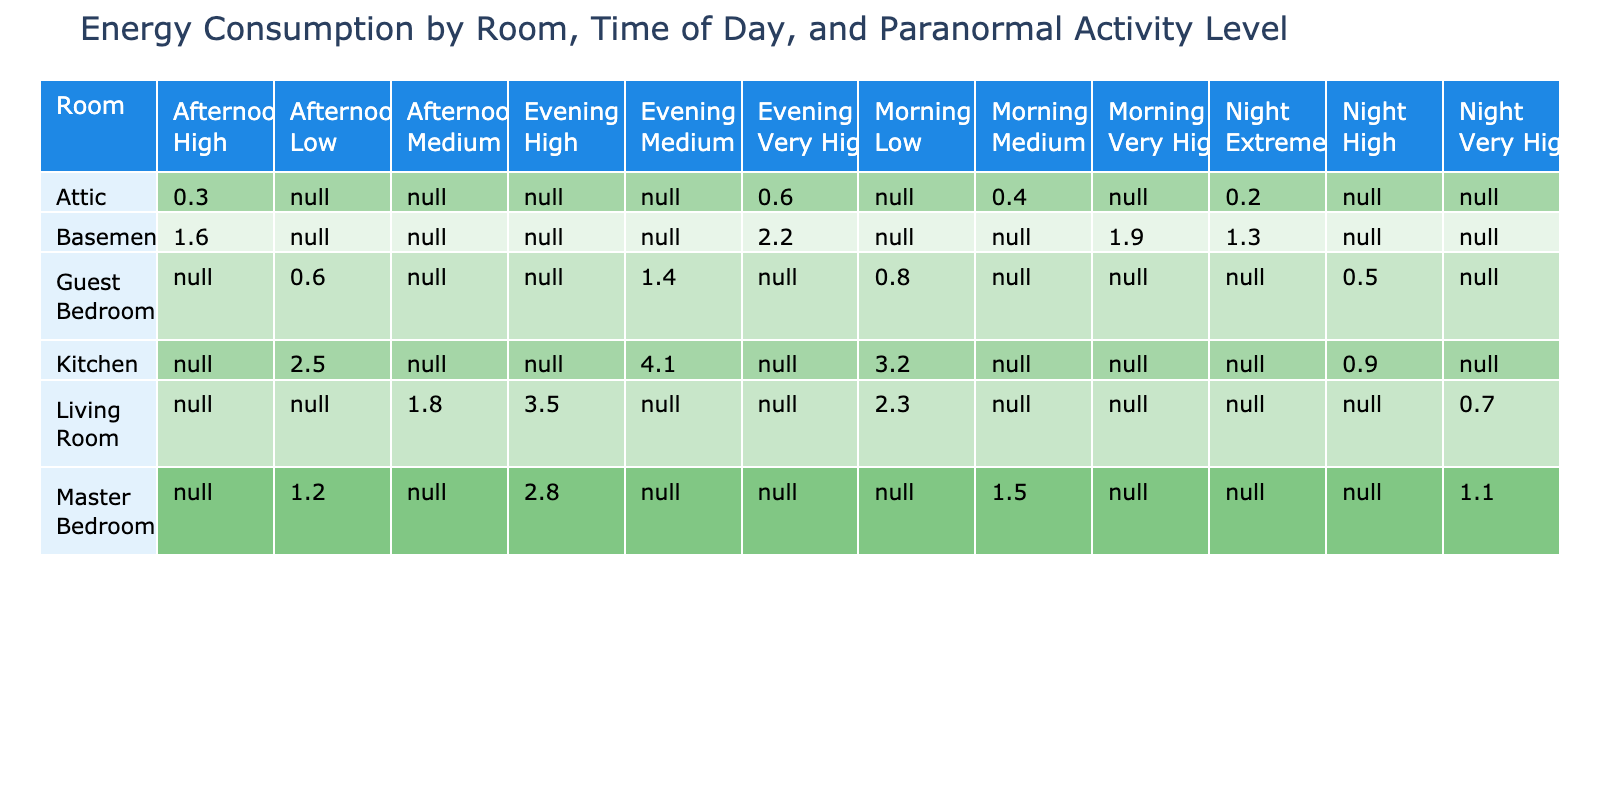What is the highest energy consumption recorded in the Living Room? The highest energy consumption in the Living Room is found in the Evening with a value of 3.5 kWh.
Answer: 3.5 kWh What is the total energy consumption for the Kitchen during daytime (Morning and Afternoon)? For the Kitchen during daytime, the energy consumption in the Morning is 3.2 kWh and in the Afternoon is 2.5 kWh. Adding these values gives 3.2 + 2.5 = 5.7 kWh total consumption.
Answer: 5.7 kWh Is the energy consumption in the Guest Bedroom higher in the Evening than in the Night? In the Guest Bedroom, the energy consumption in the Evening is 1.4 kWh, while in the Night it is 0.5 kWh. Since 1.4 kWh is greater than 0.5 kWh, the statement is true.
Answer: Yes What is the average energy consumption in the Basement during the Night? The energy consumption in the Basement at Night is 1.3 kWh, and since there is only one data point, the average is the same, which is 1.3 kWh.
Answer: 1.3 kWh Which room has the highest energy consumption during the Morning? The Kitchen has the highest energy consumption during the Morning at 3.2 kWh, compared to the Living Room's 2.3 kWh, Master Bedroom's 1.5 kWh, Guest Bedroom's 0.8 kWh, and Attic's 0.4 kWh.
Answer: Kitchen What is the difference in energy consumption between the Highest and Lowest values during the Night across all rooms? The highest energy consumption at Night is in the Living Room at 0.7 kWh and the lowest is in the Attic at 0.2 kWh. The difference is calculated as 0.7 - 0.2 = 0.5 kWh.
Answer: 0.5 kWh During which period does the Basement show the highest level of paranormal activity and what is the corresponding energy consumption? The Basement shows the highest level of paranormal activity during the Night with an Extreme level, and the corresponding energy consumption is 1.3 kWh.
Answer: Night, 1.3 kWh Does the Kitchen's energy consumption remain constant through the day? The Kitchen's energy consumption varies: it is 3.2 kWh in the Morning, 2.5 kWh in the Afternoon, 4.1 kWh in the Evening, and drops to 0.9 kWh at Night. This confirms that the consumption does not remain constant.
Answer: No 